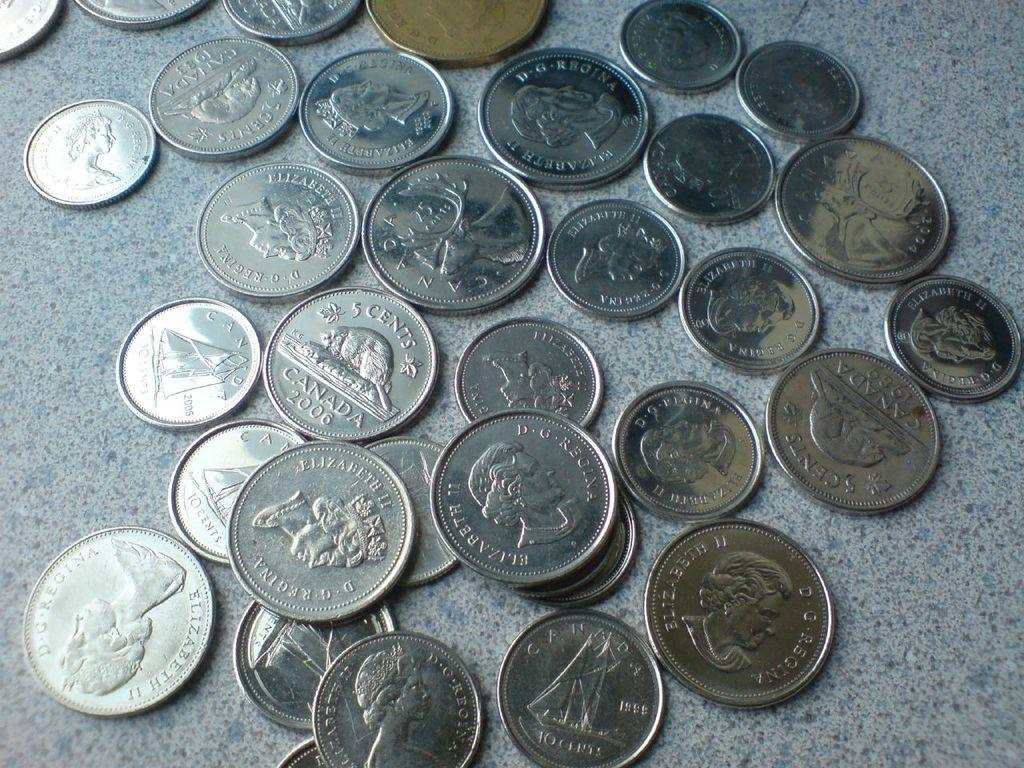<image>
Describe the image concisely. Quarters, dimes and a looney, canadian change on the counter. 